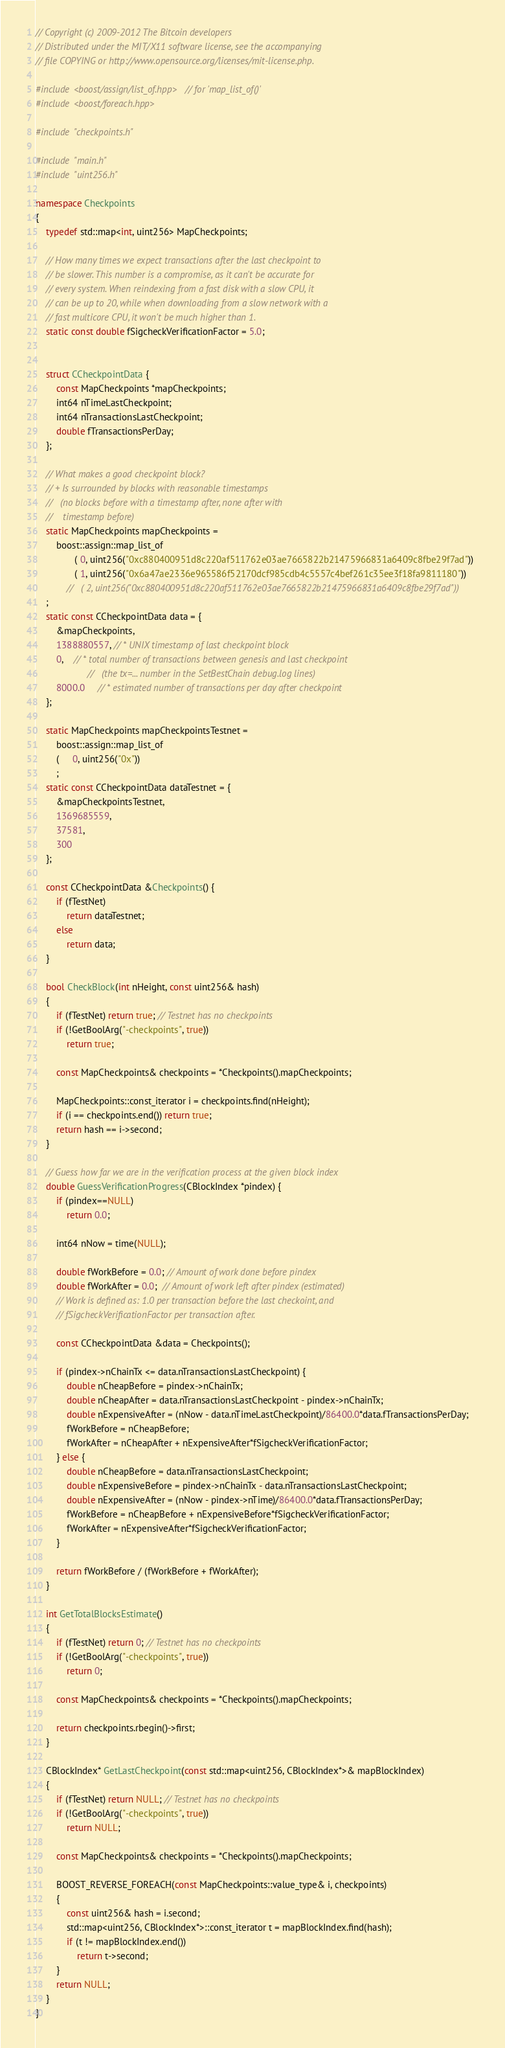Convert code to text. <code><loc_0><loc_0><loc_500><loc_500><_C++_>// Copyright (c) 2009-2012 The Bitcoin developers
// Distributed under the MIT/X11 software license, see the accompanying
// file COPYING or http://www.opensource.org/licenses/mit-license.php.

#include <boost/assign/list_of.hpp> // for 'map_list_of()'
#include <boost/foreach.hpp>

#include "checkpoints.h"

#include "main.h"
#include "uint256.h"

namespace Checkpoints
{
    typedef std::map<int, uint256> MapCheckpoints;

    // How many times we expect transactions after the last checkpoint to
    // be slower. This number is a compromise, as it can't be accurate for
    // every system. When reindexing from a fast disk with a slow CPU, it
    // can be up to 20, while when downloading from a slow network with a
    // fast multicore CPU, it won't be much higher than 1.
    static const double fSigcheckVerificationFactor = 5.0;


    struct CCheckpointData {
        const MapCheckpoints *mapCheckpoints;
        int64 nTimeLastCheckpoint;
        int64 nTransactionsLastCheckpoint;
        double fTransactionsPerDay;
    };

    // What makes a good checkpoint block?
    // + Is surrounded by blocks with reasonable timestamps
    //   (no blocks before with a timestamp after, none after with
    //    timestamp before)
    static MapCheckpoints mapCheckpoints =
        boost::assign::map_list_of
               ( 0, uint256("0xc880400951d8c220af511762e03ae7665822b21475966831a6409c8fbe29f7ad"))
			   ( 1, uint256("0x6a47ae2336e965586f52170dcf985cdb4c5557c4bef261c35ee3f18fa9811180"))
			//   ( 2, uint256("0xc880400951d8c220af511762e03ae7665822b21475966831a6409c8fbe29f7ad"))
	;
    static const CCheckpointData data = {
        &mapCheckpoints,
        1388880557, // * UNIX timestamp of last checkpoint block
        0,    // * total number of transactions between genesis and last checkpoint
                    //   (the tx=... number in the SetBestChain debug.log lines)
        8000.0     // * estimated number of transactions per day after checkpoint
    };

    static MapCheckpoints mapCheckpointsTestnet = 
        boost::assign::map_list_of
        (     0, uint256("0x"))
        ;
    static const CCheckpointData dataTestnet = {
        &mapCheckpointsTestnet,
        1369685559,
        37581,
        300
    };

    const CCheckpointData &Checkpoints() {
        if (fTestNet)
            return dataTestnet;
        else
            return data;
    }

    bool CheckBlock(int nHeight, const uint256& hash)
    {
        if (fTestNet) return true; // Testnet has no checkpoints
        if (!GetBoolArg("-checkpoints", true))
            return true;

        const MapCheckpoints& checkpoints = *Checkpoints().mapCheckpoints;

        MapCheckpoints::const_iterator i = checkpoints.find(nHeight);
        if (i == checkpoints.end()) return true;
        return hash == i->second;
    }

    // Guess how far we are in the verification process at the given block index
    double GuessVerificationProgress(CBlockIndex *pindex) {
        if (pindex==NULL)
            return 0.0;

        int64 nNow = time(NULL);

        double fWorkBefore = 0.0; // Amount of work done before pindex
        double fWorkAfter = 0.0;  // Amount of work left after pindex (estimated)
        // Work is defined as: 1.0 per transaction before the last checkoint, and
        // fSigcheckVerificationFactor per transaction after.

        const CCheckpointData &data = Checkpoints();

        if (pindex->nChainTx <= data.nTransactionsLastCheckpoint) {
            double nCheapBefore = pindex->nChainTx;
            double nCheapAfter = data.nTransactionsLastCheckpoint - pindex->nChainTx;
            double nExpensiveAfter = (nNow - data.nTimeLastCheckpoint)/86400.0*data.fTransactionsPerDay;
            fWorkBefore = nCheapBefore;
            fWorkAfter = nCheapAfter + nExpensiveAfter*fSigcheckVerificationFactor;
        } else {
            double nCheapBefore = data.nTransactionsLastCheckpoint;
            double nExpensiveBefore = pindex->nChainTx - data.nTransactionsLastCheckpoint;
            double nExpensiveAfter = (nNow - pindex->nTime)/86400.0*data.fTransactionsPerDay;
            fWorkBefore = nCheapBefore + nExpensiveBefore*fSigcheckVerificationFactor;
            fWorkAfter = nExpensiveAfter*fSigcheckVerificationFactor;
        }

        return fWorkBefore / (fWorkBefore + fWorkAfter);
    }

    int GetTotalBlocksEstimate()
    {
        if (fTestNet) return 0; // Testnet has no checkpoints
        if (!GetBoolArg("-checkpoints", true))
            return 0;

        const MapCheckpoints& checkpoints = *Checkpoints().mapCheckpoints;

        return checkpoints.rbegin()->first;
    }

    CBlockIndex* GetLastCheckpoint(const std::map<uint256, CBlockIndex*>& mapBlockIndex)
    {
        if (fTestNet) return NULL; // Testnet has no checkpoints
        if (!GetBoolArg("-checkpoints", true))
            return NULL;

        const MapCheckpoints& checkpoints = *Checkpoints().mapCheckpoints;

        BOOST_REVERSE_FOREACH(const MapCheckpoints::value_type& i, checkpoints)
        {
            const uint256& hash = i.second;
            std::map<uint256, CBlockIndex*>::const_iterator t = mapBlockIndex.find(hash);
            if (t != mapBlockIndex.end())
                return t->second;
        }
        return NULL;
    }
}
</code> 